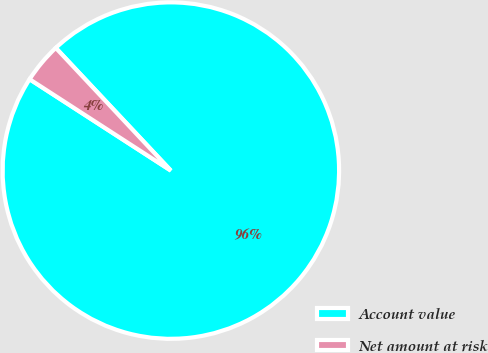Convert chart to OTSL. <chart><loc_0><loc_0><loc_500><loc_500><pie_chart><fcel>Account value<fcel>Net amount at risk<nl><fcel>96.13%<fcel>3.87%<nl></chart> 